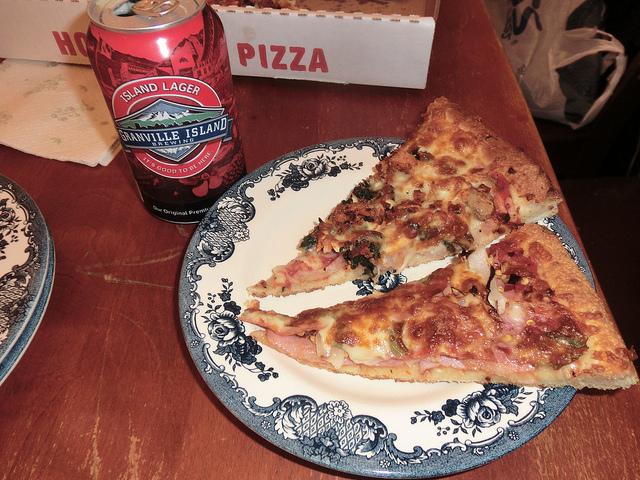What color is the platter?
Give a very brief answer. Blue and white. Where is the blue plate?
Quick response, please. On table. Is the plate designed?
Answer briefly. Yes. Is there a beverage in the image?
Concise answer only. Yes. How many slices on the plate?
Be succinct. 2. Is this a lot of pizza?
Answer briefly. No. 